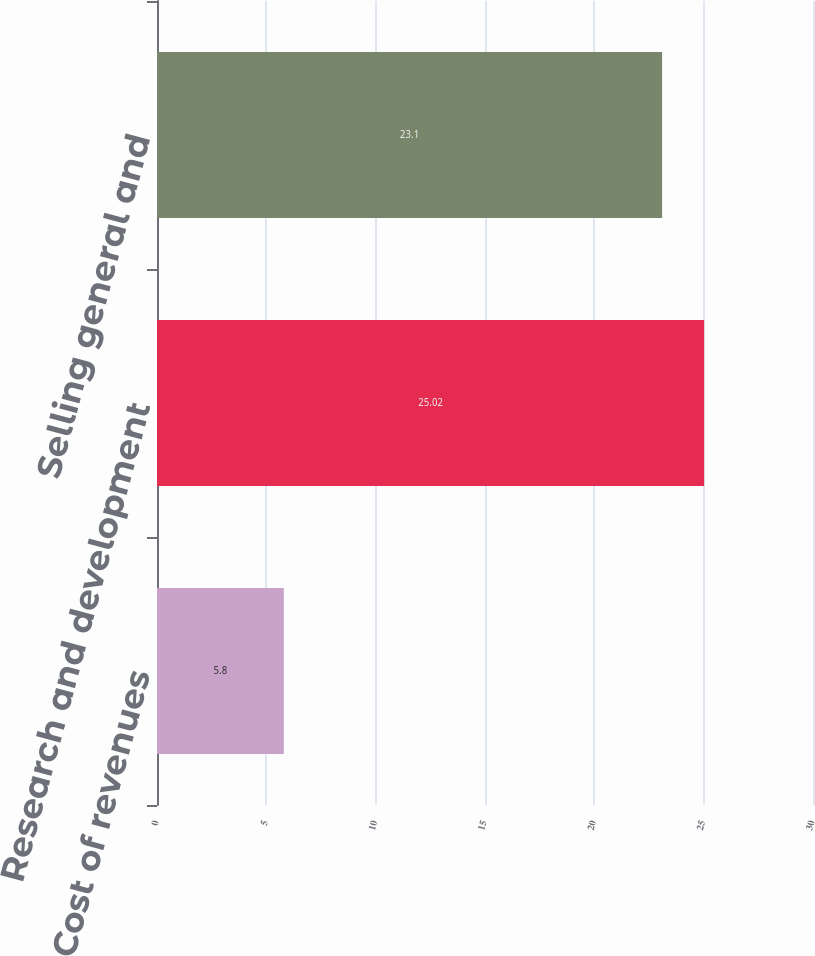<chart> <loc_0><loc_0><loc_500><loc_500><bar_chart><fcel>Cost of revenues<fcel>Research and development<fcel>Selling general and<nl><fcel>5.8<fcel>25.02<fcel>23.1<nl></chart> 